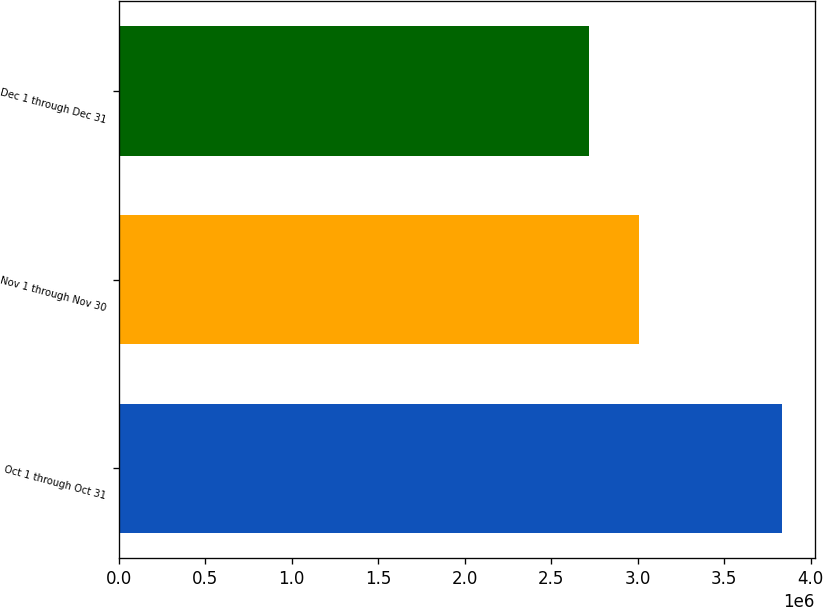<chart> <loc_0><loc_0><loc_500><loc_500><bar_chart><fcel>Oct 1 through Oct 31<fcel>Nov 1 through Nov 30<fcel>Dec 1 through Dec 31<nl><fcel>3.83164e+06<fcel>3.00522e+06<fcel>2.71832e+06<nl></chart> 